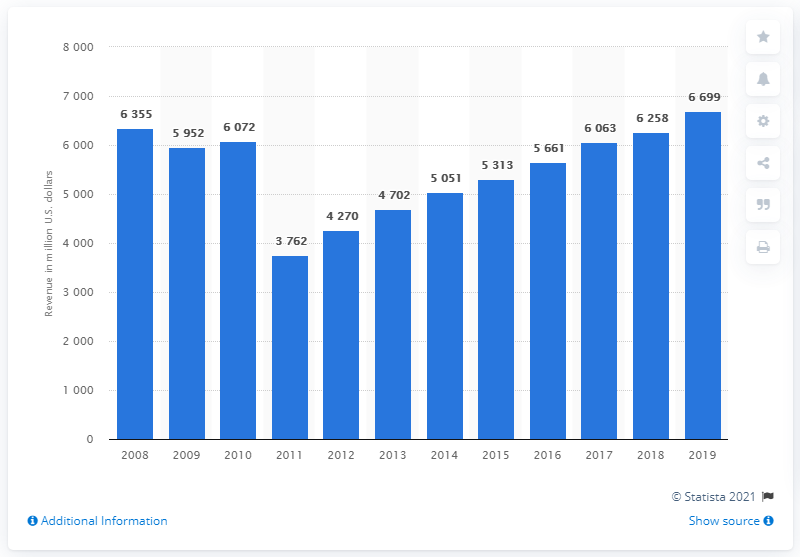List a handful of essential elements in this visual. In 2019, the total revenue of S&P Global was approximately 6,699. S&P Global's revenue in the previous year was 6,258. 